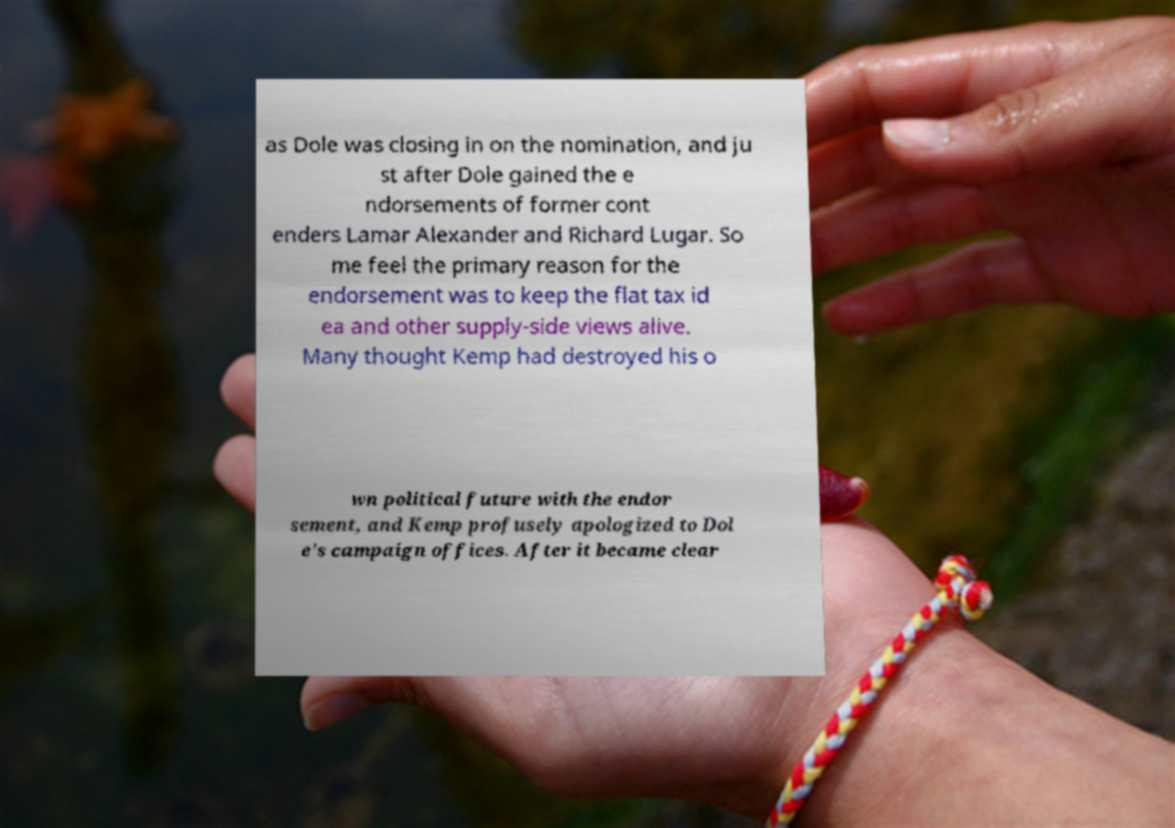What messages or text are displayed in this image? I need them in a readable, typed format. as Dole was closing in on the nomination, and ju st after Dole gained the e ndorsements of former cont enders Lamar Alexander and Richard Lugar. So me feel the primary reason for the endorsement was to keep the flat tax id ea and other supply-side views alive. Many thought Kemp had destroyed his o wn political future with the endor sement, and Kemp profusely apologized to Dol e's campaign offices. After it became clear 